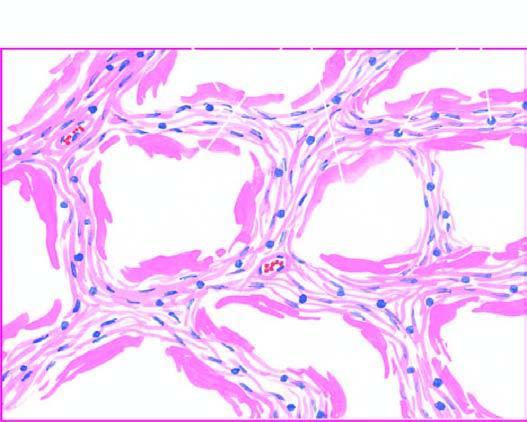what are there of collapsed and dilated alveolar spaces, many of which are lined by eosinophilic hyaline membranes?
Answer the question using a single word or phrase. Alternate areas 